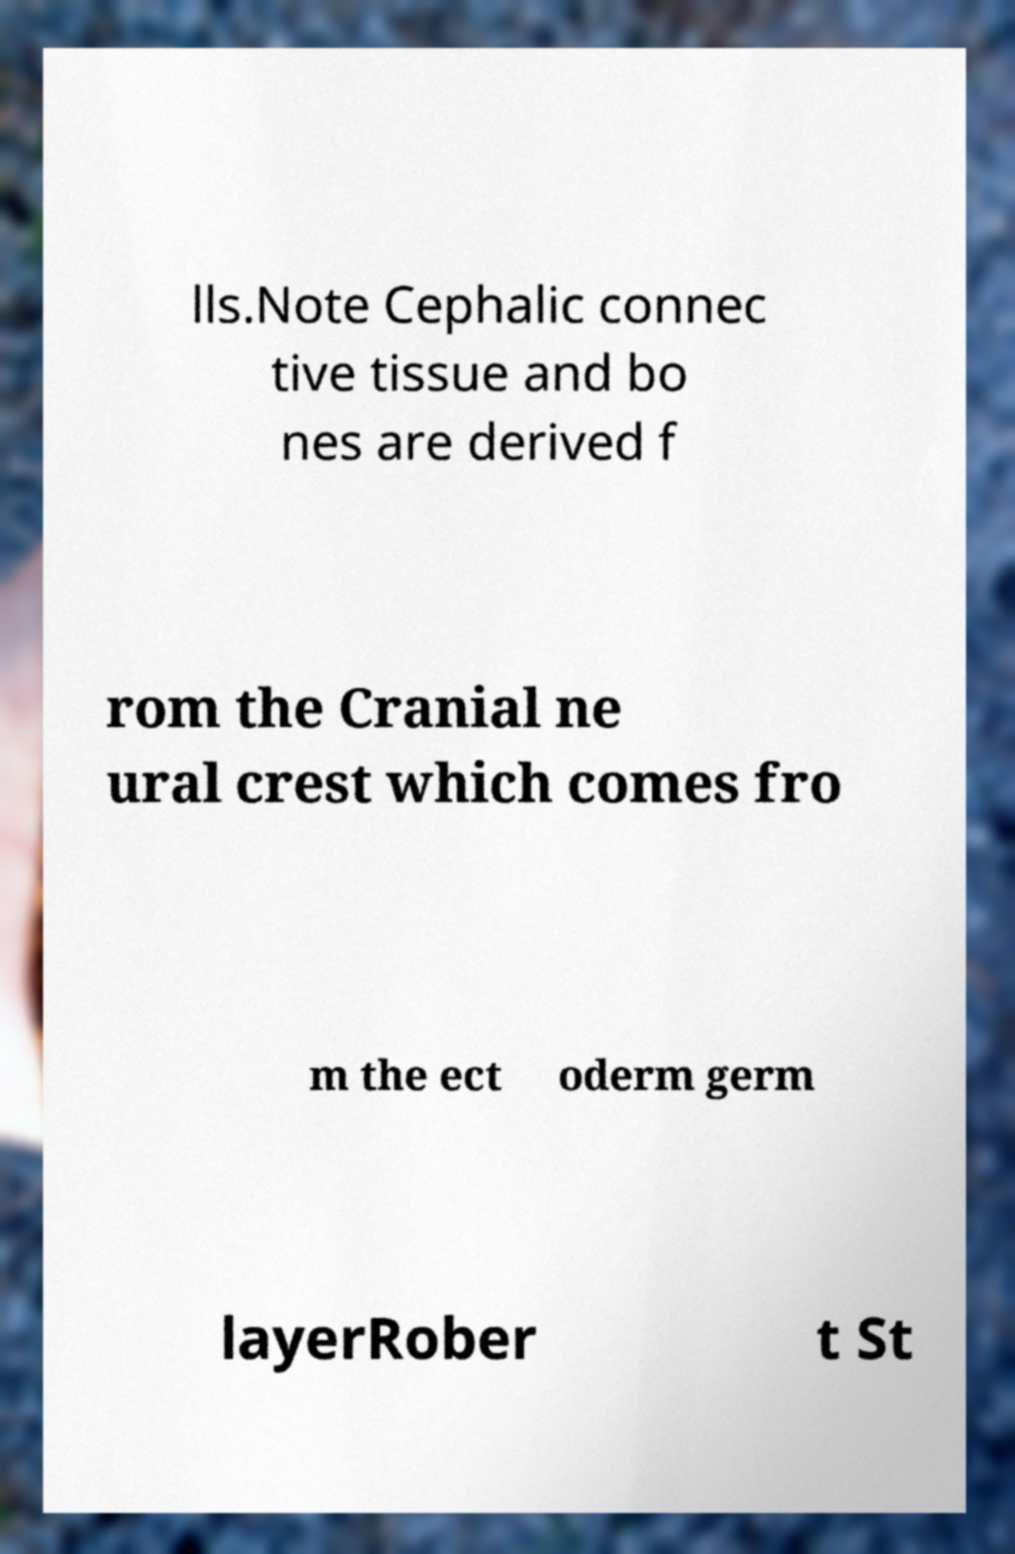Please identify and transcribe the text found in this image. lls.Note Cephalic connec tive tissue and bo nes are derived f rom the Cranial ne ural crest which comes fro m the ect oderm germ layerRober t St 